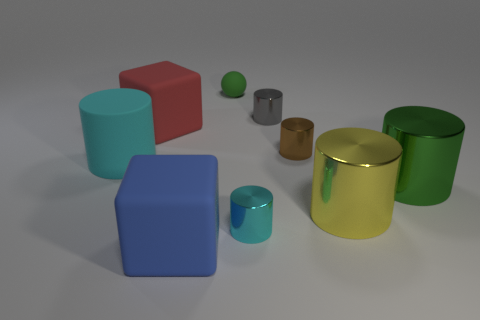There is a large rubber cube that is behind the large cyan rubber thing in front of the tiny green sphere; what is its color?
Offer a very short reply. Red. What color is the other large thing that is the same shape as the blue rubber object?
Offer a terse response. Red. How many other matte objects are the same color as the small rubber thing?
Give a very brief answer. 0. Is the color of the large rubber cylinder the same as the small cylinder that is in front of the large green metallic cylinder?
Keep it short and to the point. Yes. There is a thing that is on the right side of the gray metallic thing and to the left of the big yellow metal cylinder; what shape is it?
Keep it short and to the point. Cylinder. What is the material of the cylinder that is behind the big rubber cube that is behind the small metal thing that is in front of the green shiny cylinder?
Provide a succinct answer. Metal. Is the number of big metallic things that are in front of the green rubber sphere greater than the number of small gray cylinders in front of the tiny brown metal cylinder?
Give a very brief answer. Yes. How many tiny objects have the same material as the tiny gray cylinder?
Your answer should be very brief. 2. There is a metallic object left of the tiny gray shiny object; does it have the same shape as the green shiny object in front of the small gray object?
Provide a succinct answer. Yes. There is a matte thing that is behind the red matte cube; what is its color?
Offer a terse response. Green. 